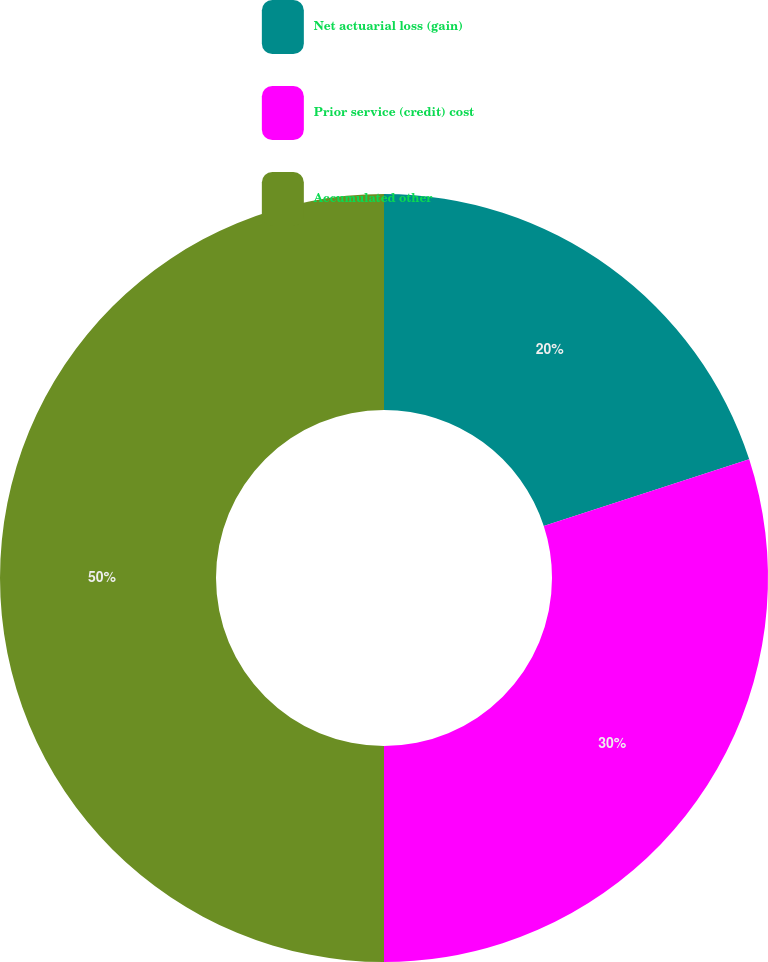Convert chart to OTSL. <chart><loc_0><loc_0><loc_500><loc_500><pie_chart><fcel>Net actuarial loss (gain)<fcel>Prior service (credit) cost<fcel>Accumulated other<nl><fcel>20.0%<fcel>30.0%<fcel>50.0%<nl></chart> 